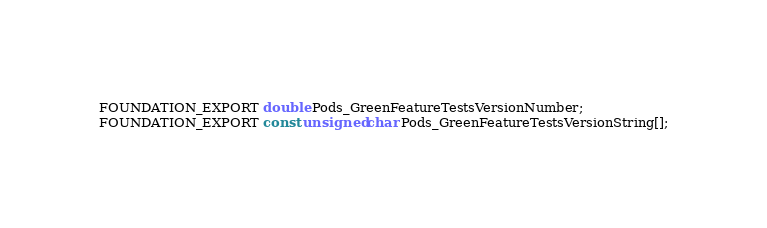<code> <loc_0><loc_0><loc_500><loc_500><_C_>
FOUNDATION_EXPORT double Pods_GreenFeatureTestsVersionNumber;
FOUNDATION_EXPORT const unsigned char Pods_GreenFeatureTestsVersionString[];

</code> 